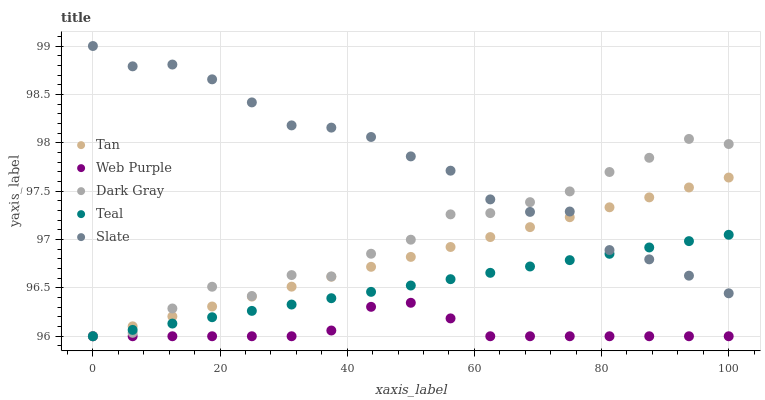Does Web Purple have the minimum area under the curve?
Answer yes or no. Yes. Does Slate have the maximum area under the curve?
Answer yes or no. Yes. Does Tan have the minimum area under the curve?
Answer yes or no. No. Does Tan have the maximum area under the curve?
Answer yes or no. No. Is Tan the smoothest?
Answer yes or no. Yes. Is Dark Gray the roughest?
Answer yes or no. Yes. Is Slate the smoothest?
Answer yes or no. No. Is Slate the roughest?
Answer yes or no. No. Does Dark Gray have the lowest value?
Answer yes or no. Yes. Does Slate have the lowest value?
Answer yes or no. No. Does Slate have the highest value?
Answer yes or no. Yes. Does Tan have the highest value?
Answer yes or no. No. Is Web Purple less than Slate?
Answer yes or no. Yes. Is Slate greater than Web Purple?
Answer yes or no. Yes. Does Slate intersect Teal?
Answer yes or no. Yes. Is Slate less than Teal?
Answer yes or no. No. Is Slate greater than Teal?
Answer yes or no. No. Does Web Purple intersect Slate?
Answer yes or no. No. 